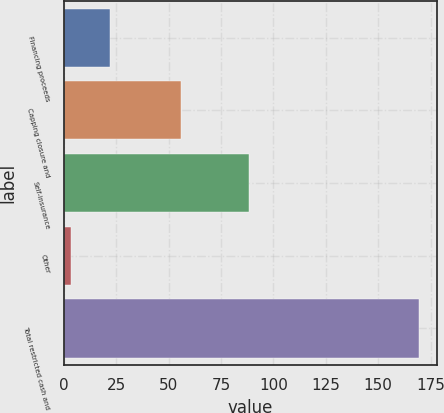Convert chart to OTSL. <chart><loc_0><loc_0><loc_500><loc_500><bar_chart><fcel>Financing proceeds<fcel>Capping closure and<fcel>Self-insurance<fcel>Other<fcel>Total restricted cash and<nl><fcel>21.9<fcel>56<fcel>88.4<fcel>3.4<fcel>169.7<nl></chart> 